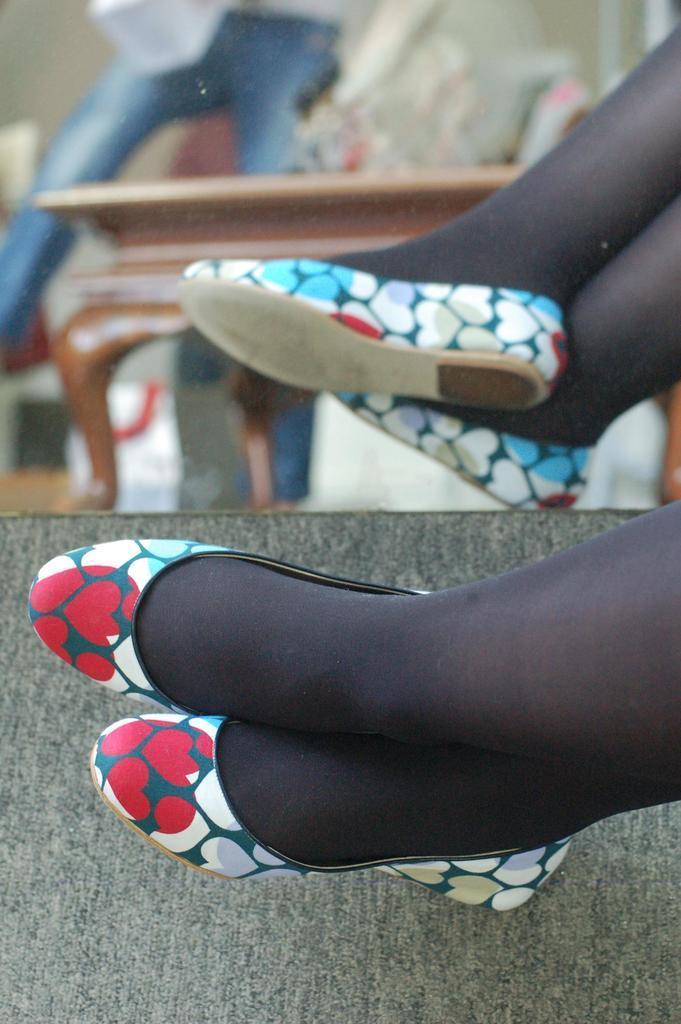Can you describe this image briefly? In this image I can see a leg of a person and here I can see a reflection in a mirror. 